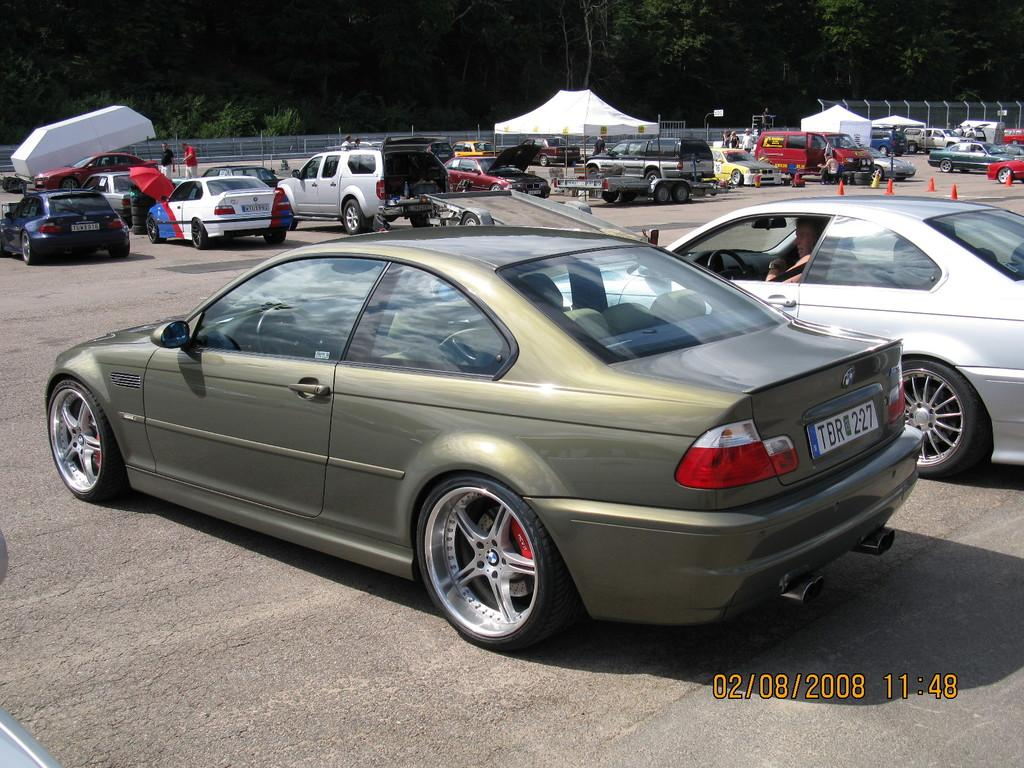What can you describe the natural elements in the background of the image? There are trees in the background of the image. What type of shelter is present in the image? There is a tent in white color in the image. What type of man-made structure can be seen in the image? There is a road in the image. What type of transportation is visible in the image? Vehicles are visible in the image. What safety feature is present in the image? There are traffic cones in the image. What type of barrier is present in the image? There is a fence in the image. What type of pets can be seen playing with rice in the image? There are no pets or rice present in the image. What type of winter activity is taking place in the image? There is no winter activity depicted in the image. 